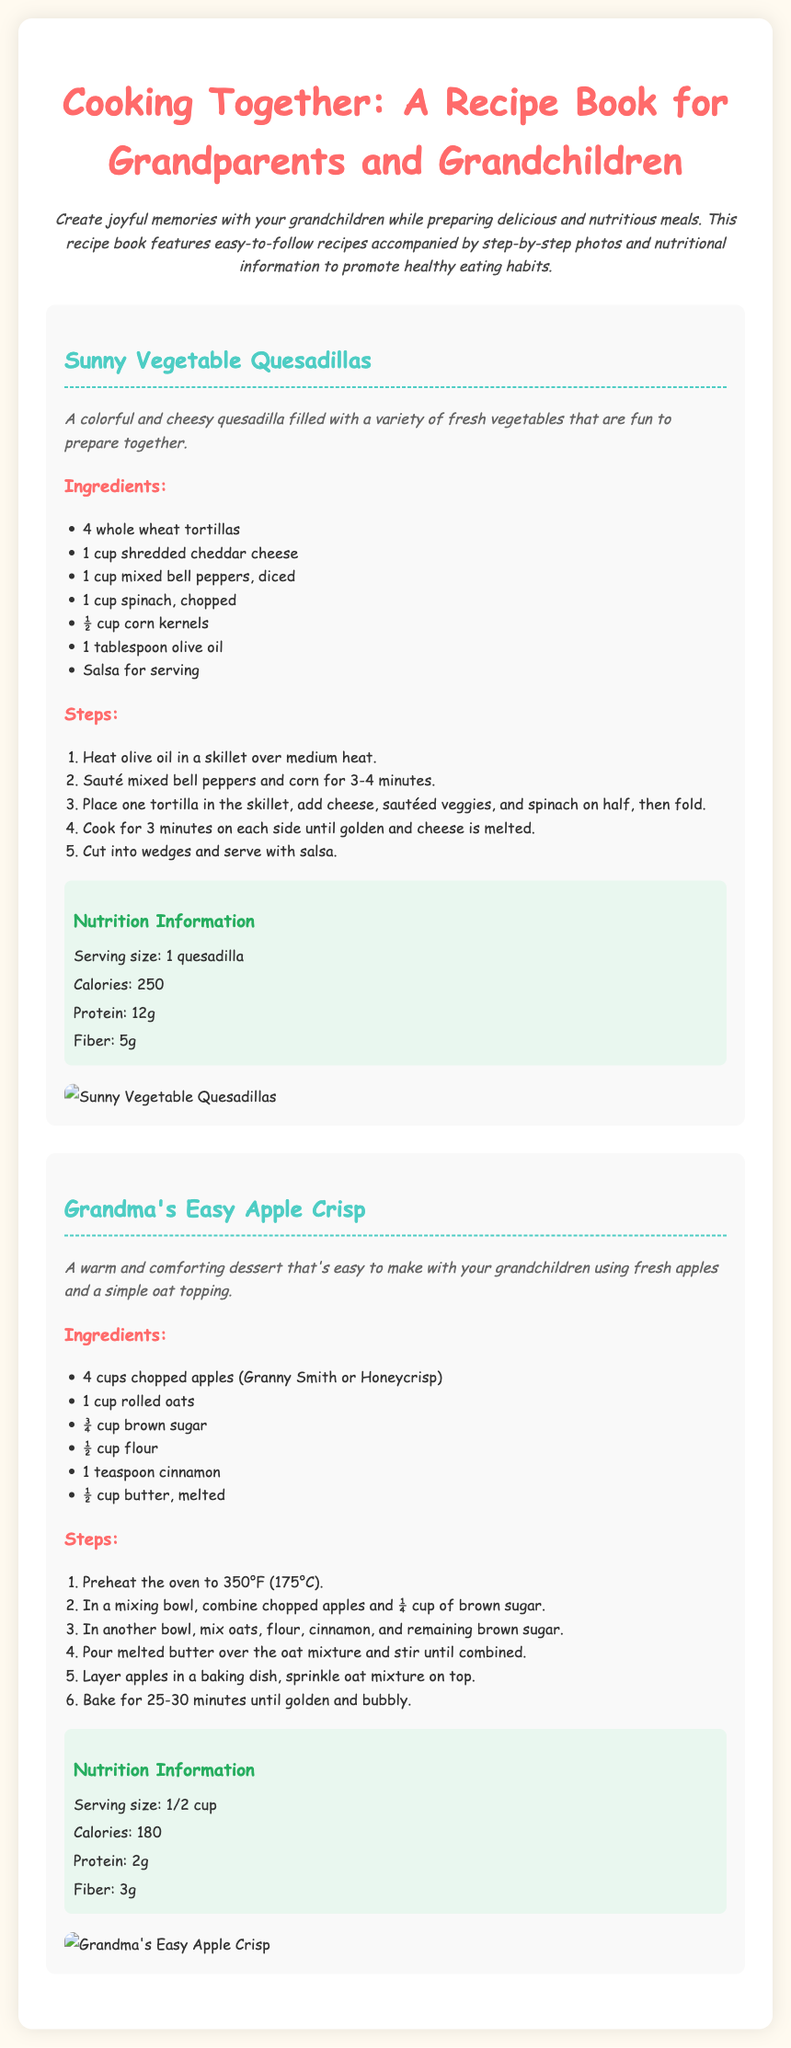What is the title of the recipe book? The title can be found prominently at the top of the document.
Answer: Cooking Together: A Recipe Book for Grandparents and Grandchildren How many recipes are included in the document? The document features two complete recipes that can be seen in the content.
Answer: 2 What ingredient is used in Grandma's Easy Apple Crisp? The ingredient list for the dessert shows the main components clearly.
Answer: Apples What is the serving size for Sunny Vegetable Quesadillas? The nutritional information section provides details about serving sizes.
Answer: 1 quesadilla What temperature should the oven be preheated to for Grandma's Easy Apple Crisp? The steps for making the dessert state the required oven temperature.
Answer: 350°F (175°C) Which vegetable is included in the Sunny Vegetable Quesadillas? The ingredients list specifies various vegetables needed for this recipe.
Answer: Spinach How long do you bake Grandma's Easy Apple Crisp? The steps to prepare the dessert mention the baking duration.
Answer: 25-30 minutes What color are the quesadillas? The recipe description indicates the appearance of the quesadillas.
Answer: Colorful What action is suggested for the mixed bell peppers in the quesadilla recipe? The steps detail what to do with the mixed bell peppers during cooking.
Answer: Sauté 